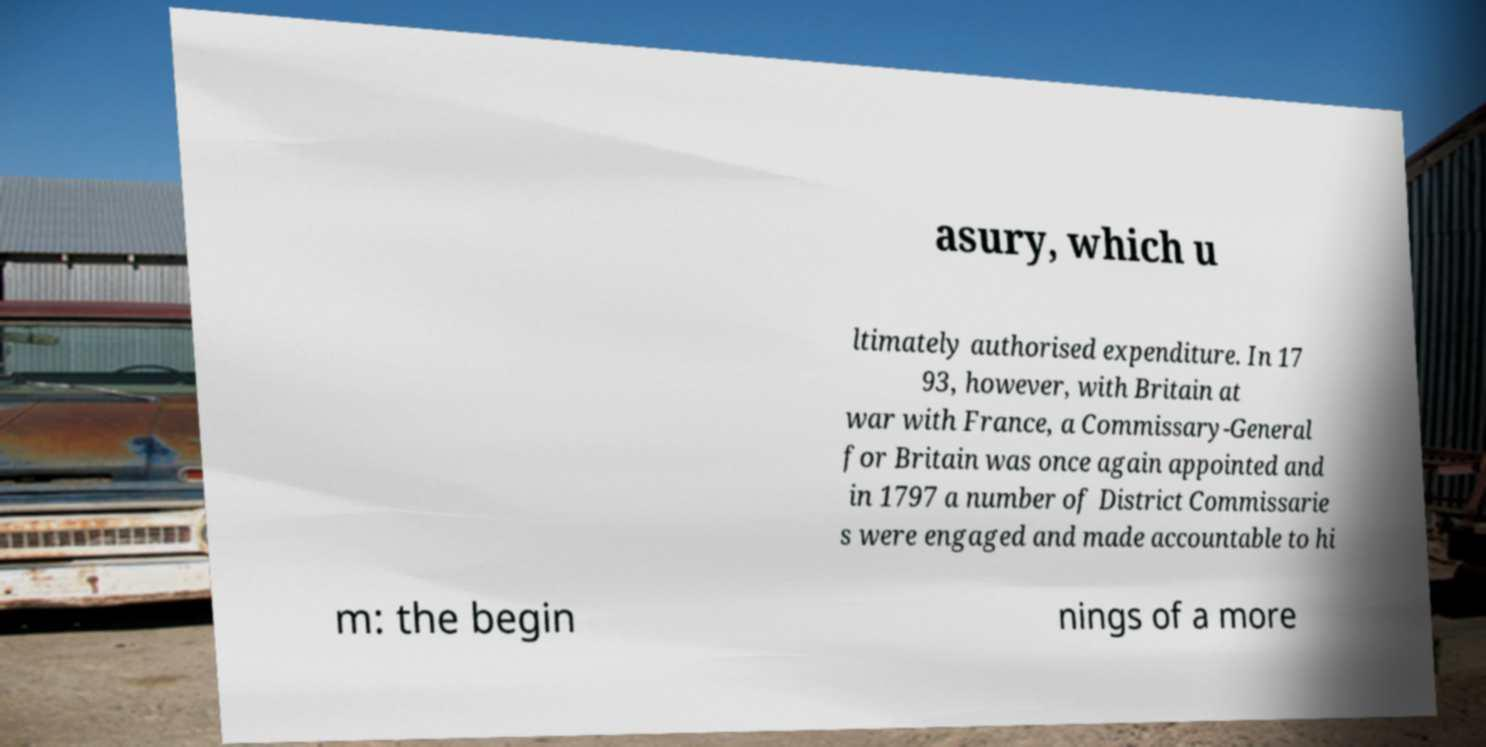Please identify and transcribe the text found in this image. asury, which u ltimately authorised expenditure. In 17 93, however, with Britain at war with France, a Commissary-General for Britain was once again appointed and in 1797 a number of District Commissarie s were engaged and made accountable to hi m: the begin nings of a more 